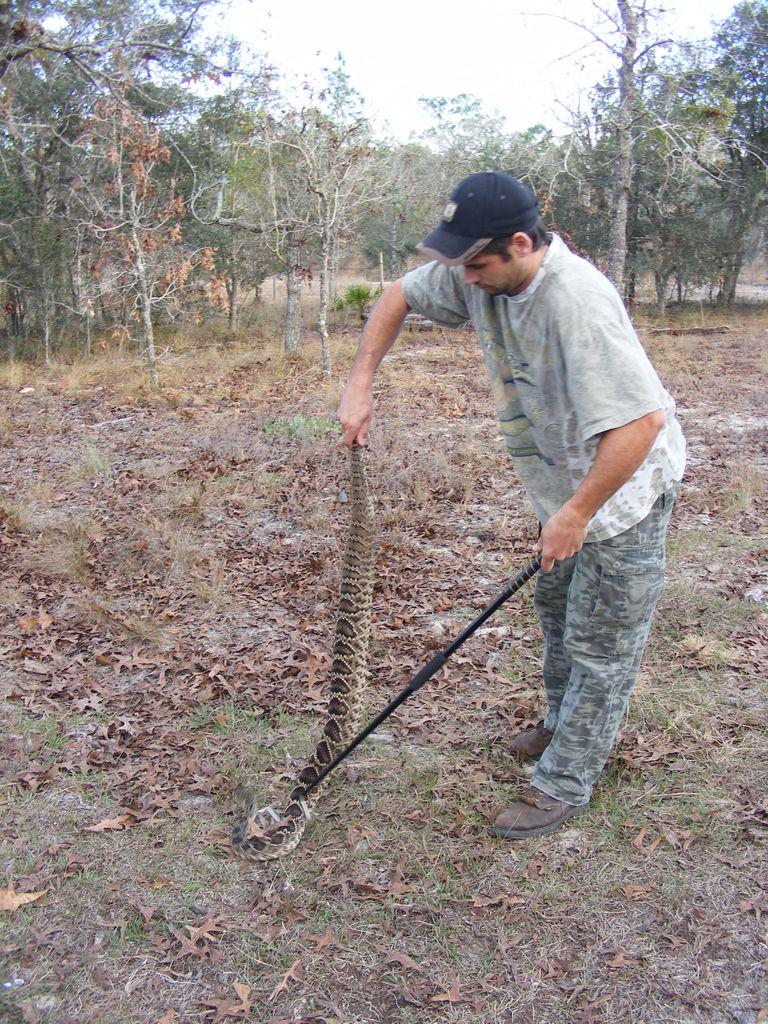What is the main subject of the image? There is a person in the image. What is the person holding in the image? The person is holding a snake and a stick. What type of vegetation can be seen in the image? There are trees in the image, and leaves are on the ground. What is visible in the background of the image? The sky is visible in the image. How many fangs can be seen on the person's throat in the image? There are no fangs or any indication of a person's throat being bitten in the image. 